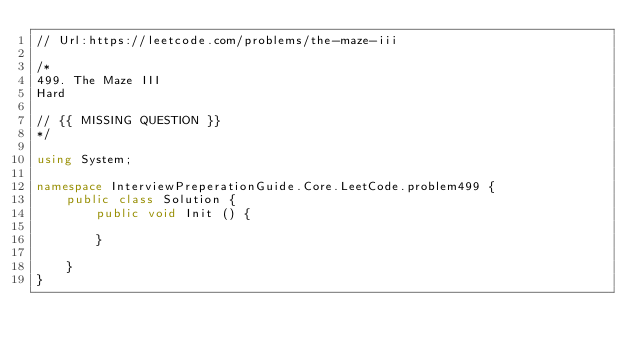<code> <loc_0><loc_0><loc_500><loc_500><_C#_>// Url:https://leetcode.com/problems/the-maze-iii

/*
499. The Maze III
Hard

// {{ MISSING QUESTION }}
*/

using System;

namespace InterviewPreperationGuide.Core.LeetCode.problem499 {
    public class Solution {
        public void Init () {

        }

    }
}</code> 